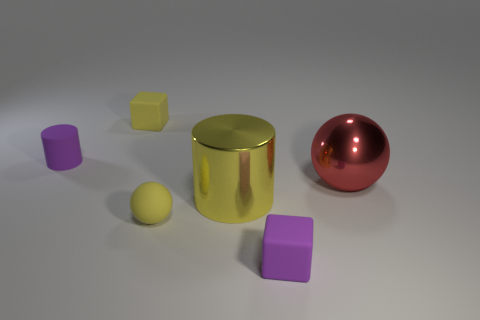Add 2 yellow rubber spheres. How many objects exist? 8 Subtract all balls. How many objects are left? 4 Subtract all purple matte things. Subtract all large yellow metal cylinders. How many objects are left? 3 Add 5 spheres. How many spheres are left? 7 Add 6 yellow matte blocks. How many yellow matte blocks exist? 7 Subtract 0 red cubes. How many objects are left? 6 